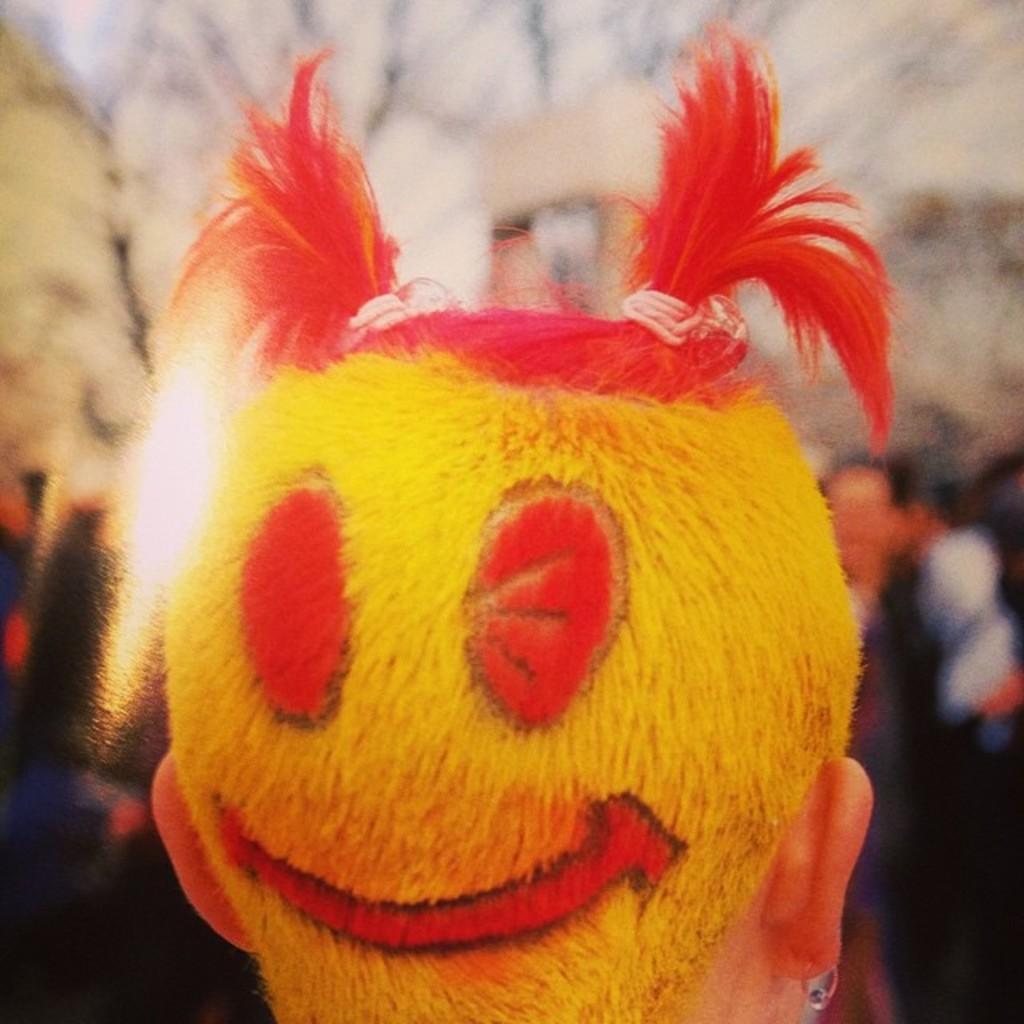Please provide a concise description of this image. In front of the picture, we see the head of the man who is wearing the two plaits. His hairs are in yellow and red color. On the right side, we see the people are standing. In the background, we see a white wall, sky and the trees. This picture is blurred in the background. 